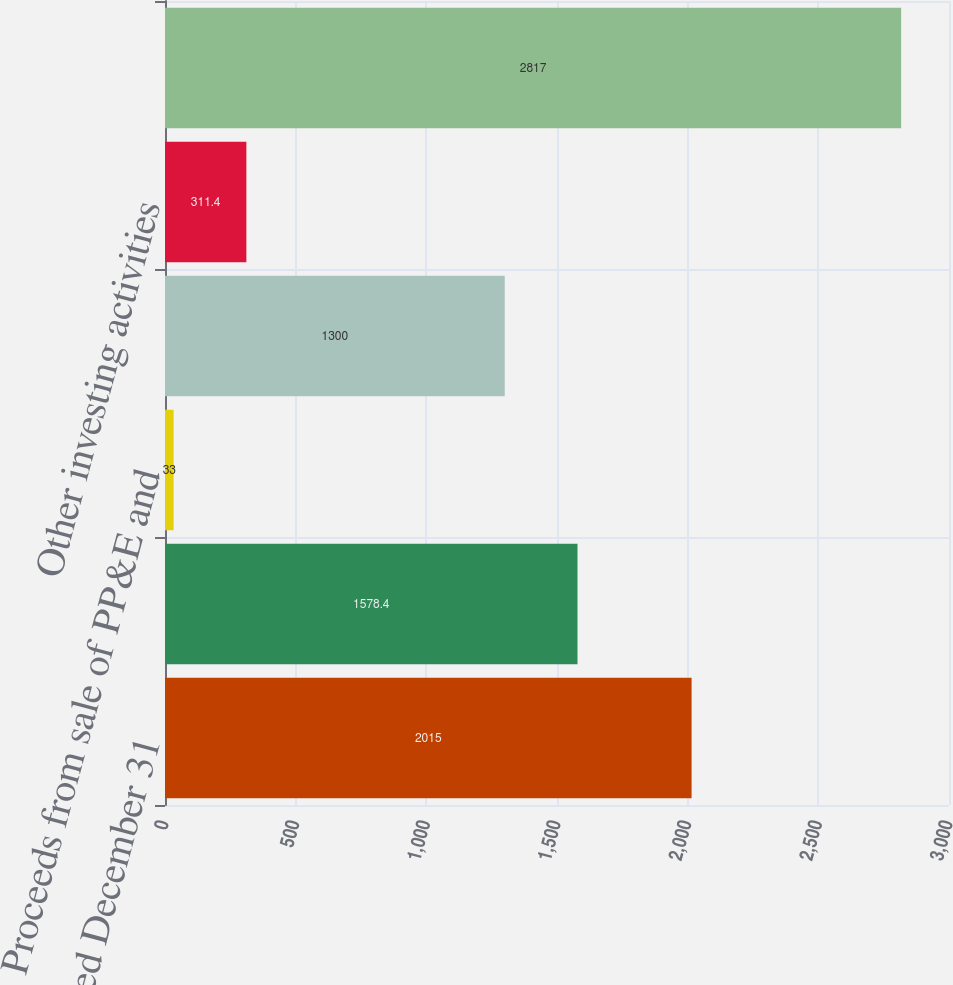<chart> <loc_0><loc_0><loc_500><loc_500><bar_chart><fcel>Years ended December 31<fcel>Purchases of property plant<fcel>Proceeds from sale of PP&E and<fcel>Purchases and proceeds from<fcel>Other investing activities<fcel>Net cash used in investing<nl><fcel>2015<fcel>1578.4<fcel>33<fcel>1300<fcel>311.4<fcel>2817<nl></chart> 